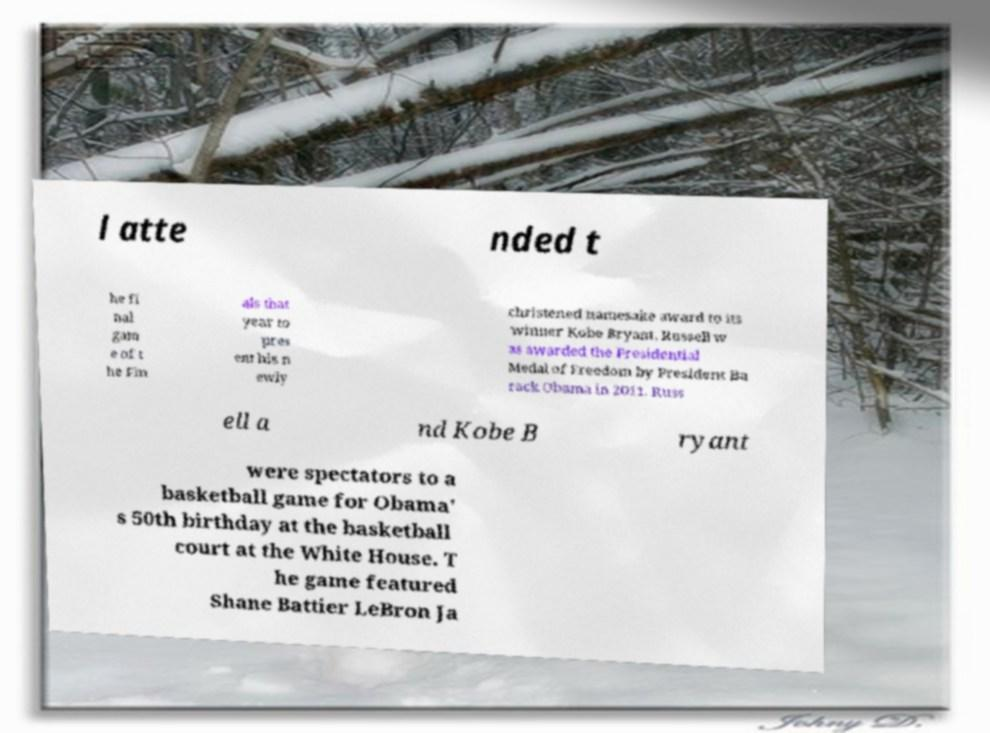There's text embedded in this image that I need extracted. Can you transcribe it verbatim? l atte nded t he fi nal gam e of t he Fin als that year to pres ent his n ewly christened namesake award to its winner Kobe Bryant. Russell w as awarded the Presidential Medal of Freedom by President Ba rack Obama in 2011. Russ ell a nd Kobe B ryant were spectators to a basketball game for Obama' s 50th birthday at the basketball court at the White House. T he game featured Shane Battier LeBron Ja 